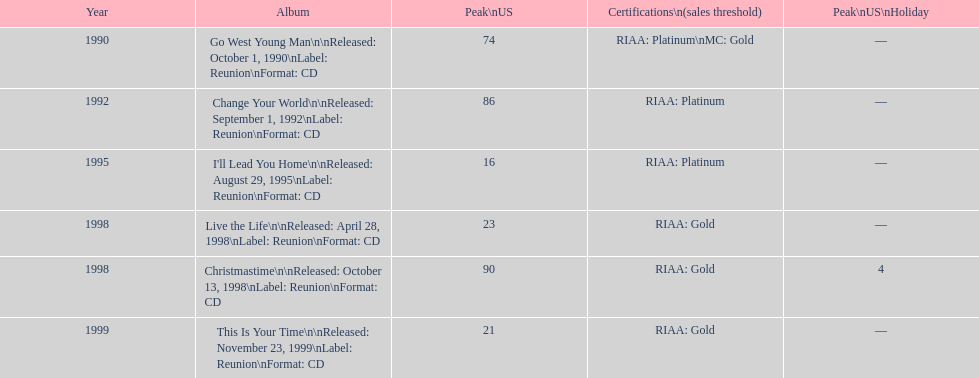What was the first michael w smith album? Go West Young Man. 